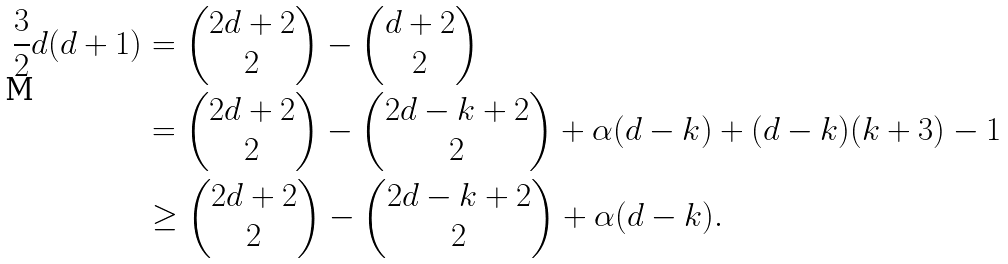Convert formula to latex. <formula><loc_0><loc_0><loc_500><loc_500>\frac { 3 } { 2 } d ( d + 1 ) & = \begin{pmatrix} 2 d + 2 \\ 2 \end{pmatrix} - \begin{pmatrix} d + 2 \\ 2 \end{pmatrix} \\ & = \begin{pmatrix} 2 d + 2 \\ 2 \end{pmatrix} - \begin{pmatrix} 2 d - k + 2 \\ 2 \end{pmatrix} + \alpha ( d - k ) + ( d - k ) ( k + 3 ) - 1 \\ & \geq \begin{pmatrix} 2 d + 2 \\ 2 \end{pmatrix} - \begin{pmatrix} 2 d - k + 2 \\ 2 \end{pmatrix} + \alpha ( d - k ) .</formula> 